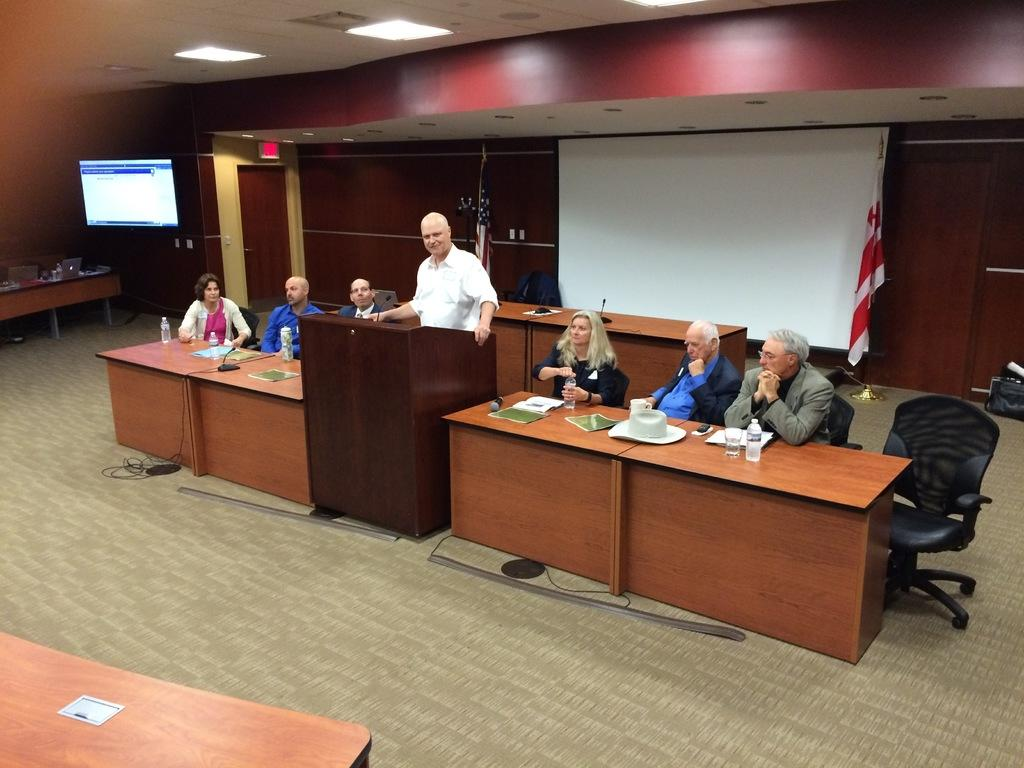What is present in the room that displays information or images? There is a screen in the room. What type of seating is available in the room? There are benches in the room. How many people are present in the room? There are seven people in the room. What are the majority of the people doing in the room? Six of the people are sitting on chairs. Is there anyone standing in the room? Yes, one person is standing. What type of land can be seen through the window in the room? There is no window or land visible in the image; it only shows a screen, benches, and people in the room. What tool is being used by one of the people to create a recess in the wall? There is no tool or recess-making activity present in the image. 